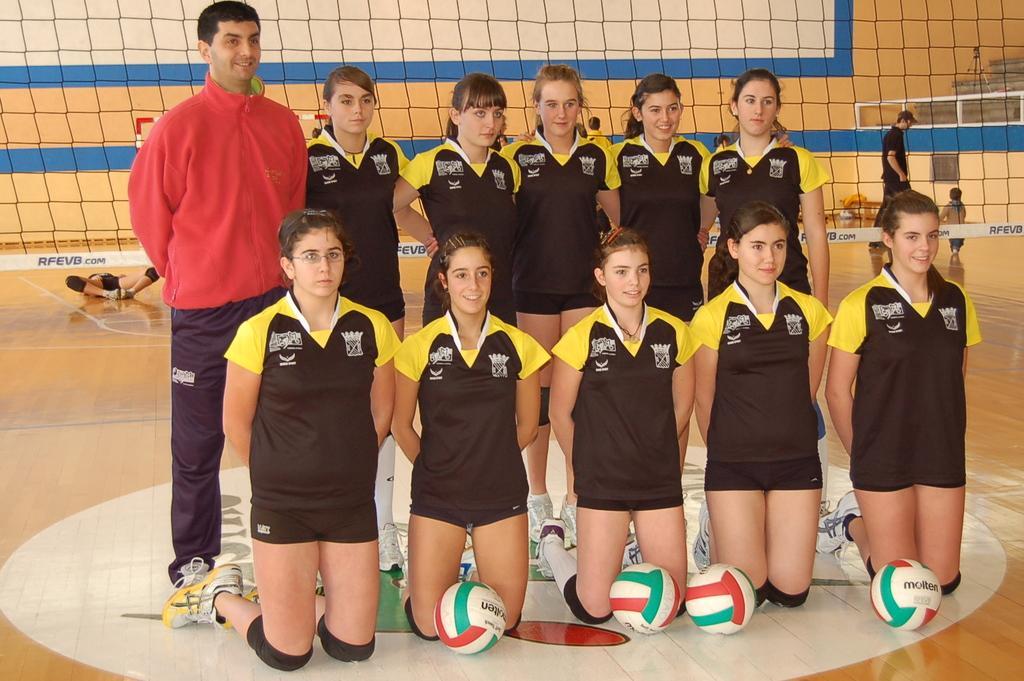How would you summarize this image in a sentence or two? In this picture we can see some people are standing and some people are in squat position and a person is lying on the floor and on the floor there are balls. Behind the people there is a net and a wall and on the right side of the people there is a stand. 